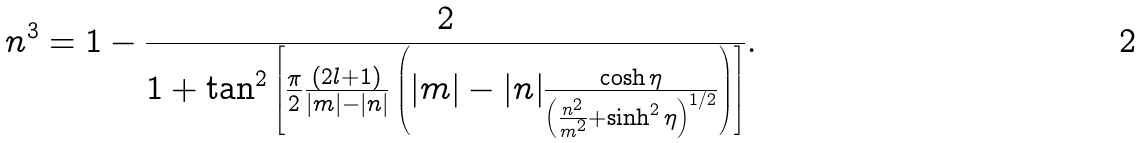Convert formula to latex. <formula><loc_0><loc_0><loc_500><loc_500>n ^ { 3 } = 1 - \frac { 2 } { 1 + \tan ^ { 2 } \left [ \frac { \pi } { 2 } \frac { ( 2 l + 1 ) } { | m | - | n | } \left ( | m | - | n | \frac { \cosh \eta } { \left ( \frac { n ^ { 2 } } { m ^ { 2 } } + \sinh ^ { 2 } \eta \right ) ^ { 1 / 2 } } \right ) \right ] } .</formula> 